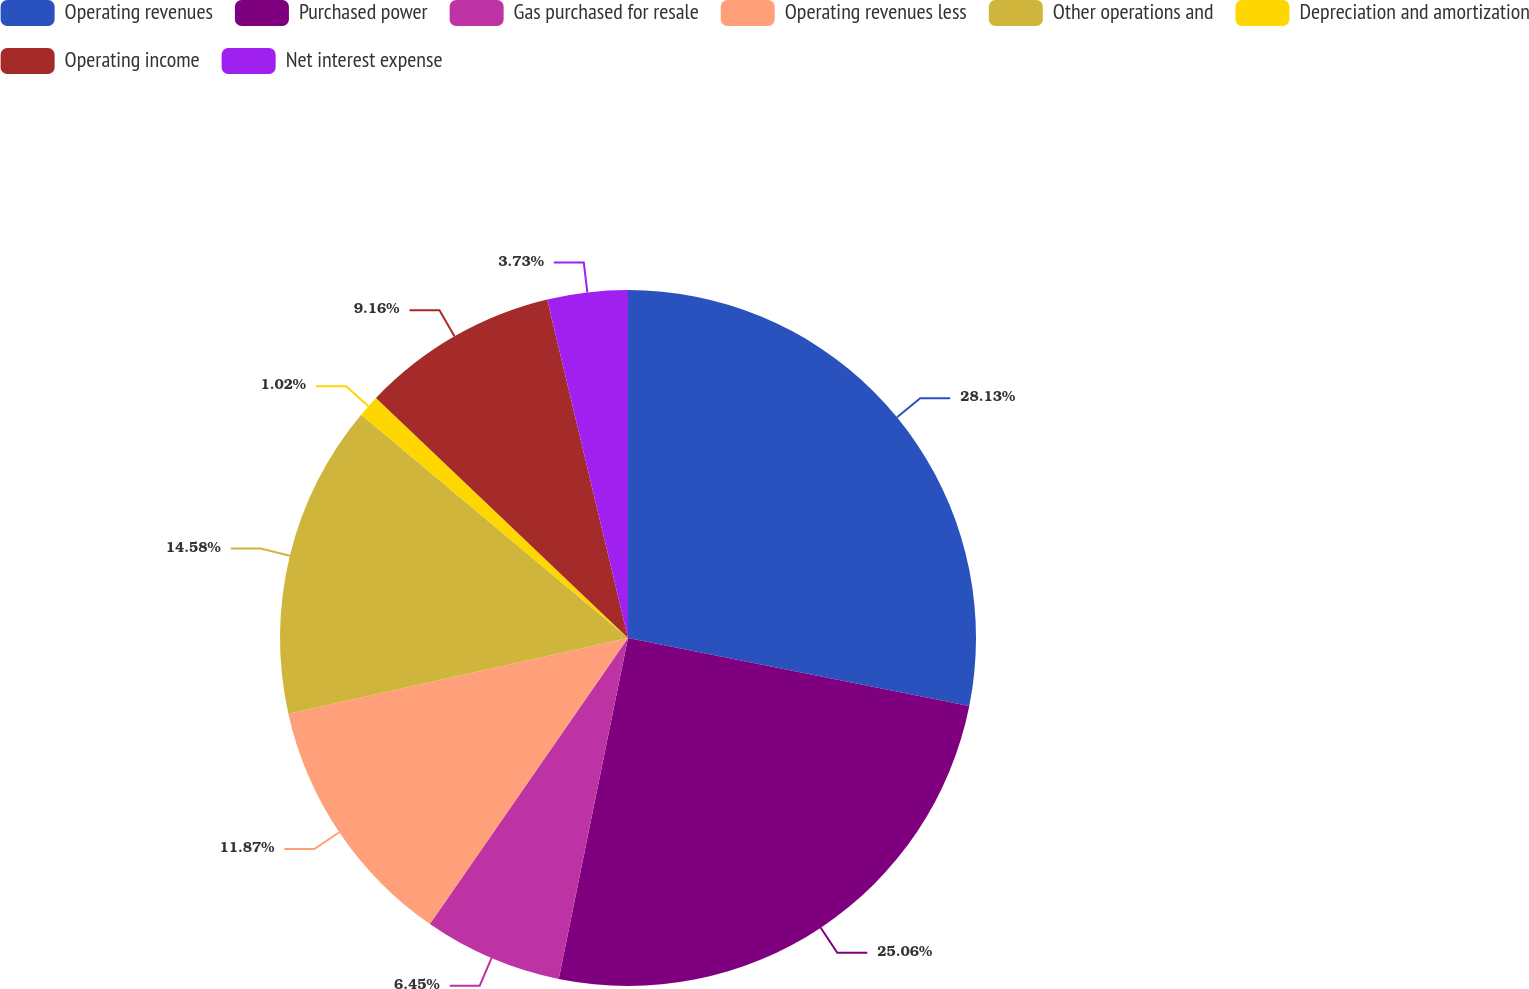<chart> <loc_0><loc_0><loc_500><loc_500><pie_chart><fcel>Operating revenues<fcel>Purchased power<fcel>Gas purchased for resale<fcel>Operating revenues less<fcel>Other operations and<fcel>Depreciation and amortization<fcel>Operating income<fcel>Net interest expense<nl><fcel>28.13%<fcel>25.06%<fcel>6.45%<fcel>11.87%<fcel>14.58%<fcel>1.02%<fcel>9.16%<fcel>3.73%<nl></chart> 